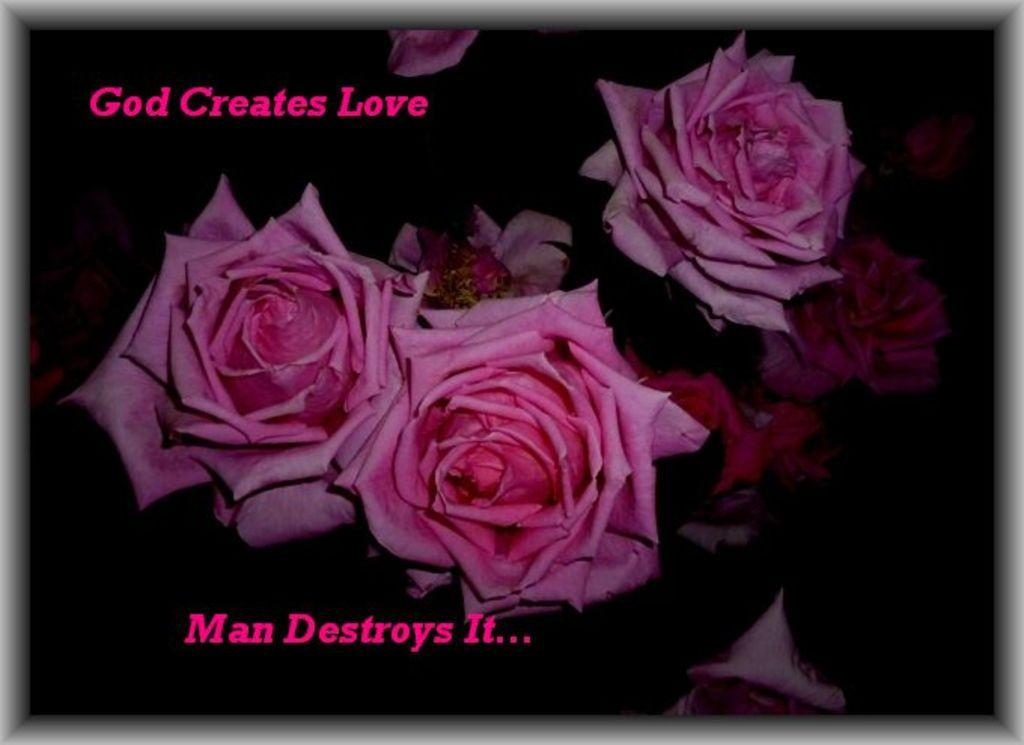What is depicted on the poster in the image? There is a poster of flowers in the image. What is the color of the background in the image? The background of the image is dark. What else can be seen in the image besides the poster? There is text visible in the image. How many knee-high jellyfish can be seen in the image? There are no jellyfish, knee-high or otherwise, present in the image. What invention is being advertised on the poster in the image? The poster in the image features flowers, not an invention. 